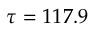Convert formula to latex. <formula><loc_0><loc_0><loc_500><loc_500>\tau = 1 1 7 . 9</formula> 